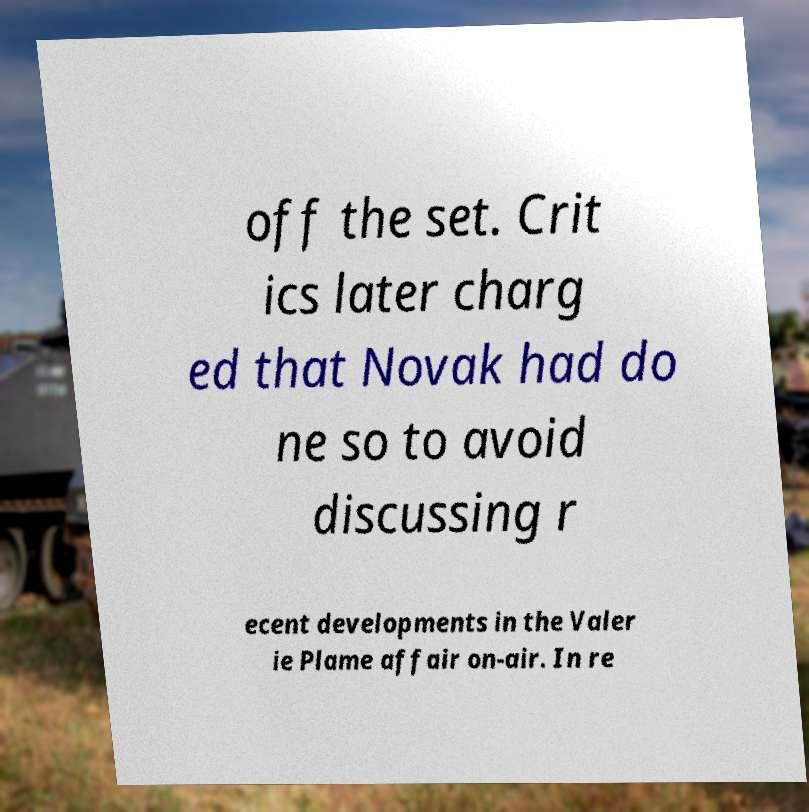There's text embedded in this image that I need extracted. Can you transcribe it verbatim? off the set. Crit ics later charg ed that Novak had do ne so to avoid discussing r ecent developments in the Valer ie Plame affair on-air. In re 